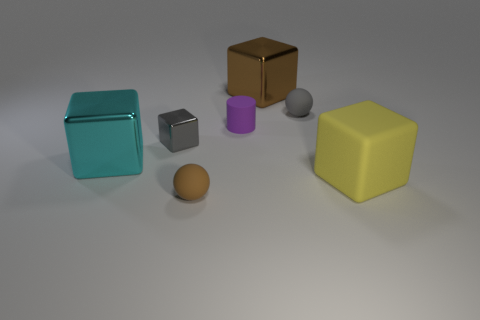Does the gray matte object have the same size as the brown thing behind the cyan block?
Your response must be concise. No. What number of things have the same material as the gray sphere?
Provide a succinct answer. 3. Do the yellow rubber object and the brown rubber ball have the same size?
Provide a succinct answer. No. Are there any other things of the same color as the tiny cube?
Make the answer very short. Yes. What is the shape of the tiny thing that is right of the small gray cube and left of the tiny purple cylinder?
Your answer should be compact. Sphere. What is the size of the metallic block that is behind the small gray ball?
Offer a very short reply. Large. There is a metal cube that is on the right side of the small rubber thing that is in front of the purple rubber cylinder; how many cyan blocks are behind it?
Your response must be concise. 0. There is a tiny gray cube; are there any big yellow rubber things to the right of it?
Your response must be concise. Yes. What number of other objects are there of the same size as the purple cylinder?
Keep it short and to the point. 3. The cube that is both in front of the small gray metallic object and to the left of the large brown metallic thing is made of what material?
Your answer should be very brief. Metal. 